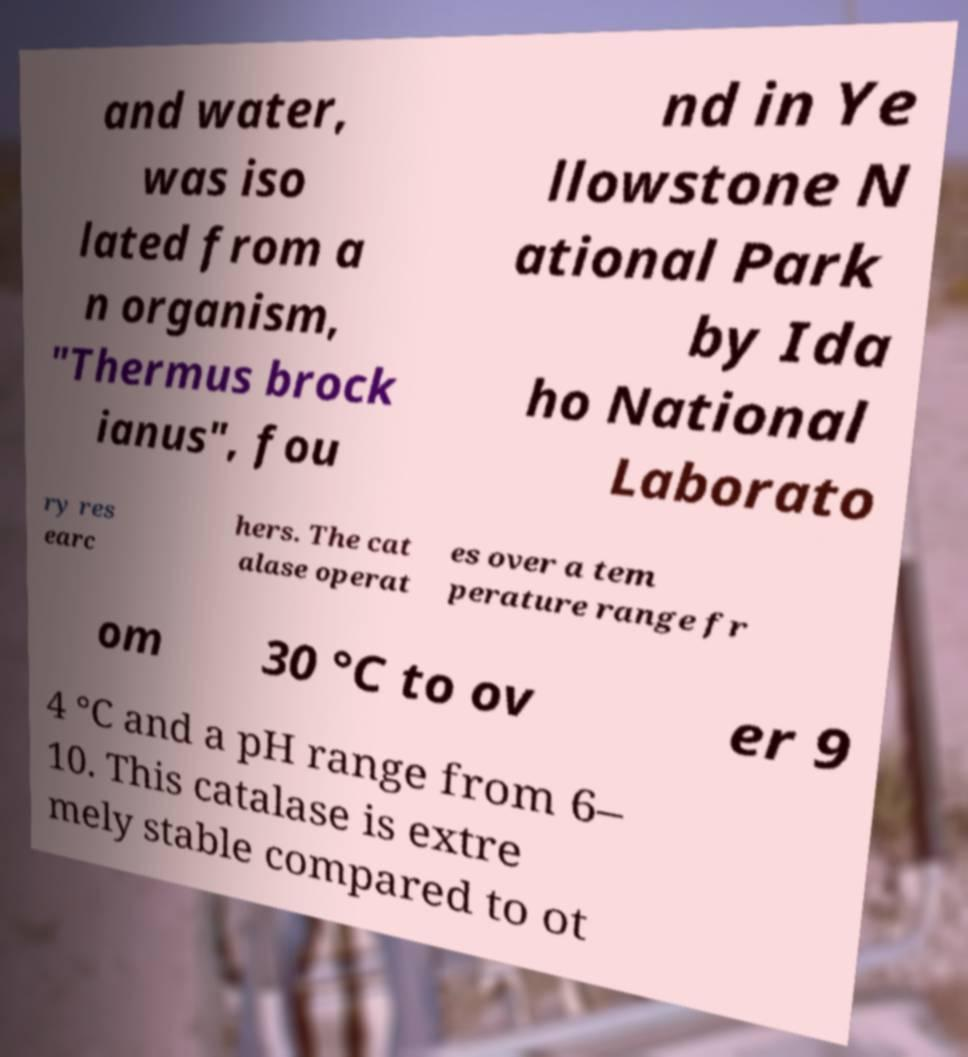For documentation purposes, I need the text within this image transcribed. Could you provide that? and water, was iso lated from a n organism, "Thermus brock ianus", fou nd in Ye llowstone N ational Park by Ida ho National Laborato ry res earc hers. The cat alase operat es over a tem perature range fr om 30 °C to ov er 9 4 °C and a pH range from 6– 10. This catalase is extre mely stable compared to ot 